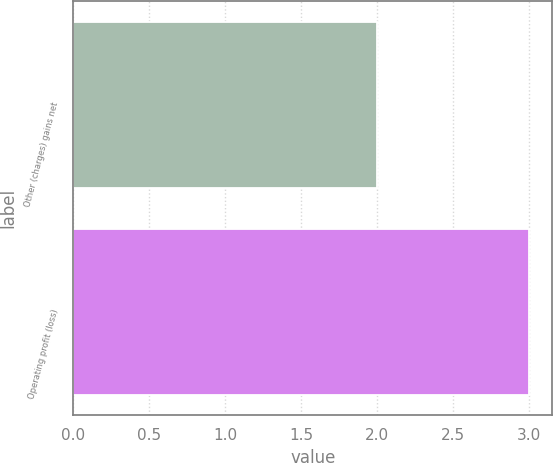<chart> <loc_0><loc_0><loc_500><loc_500><bar_chart><fcel>Other (charges) gains net<fcel>Operating profit (loss)<nl><fcel>2<fcel>3<nl></chart> 